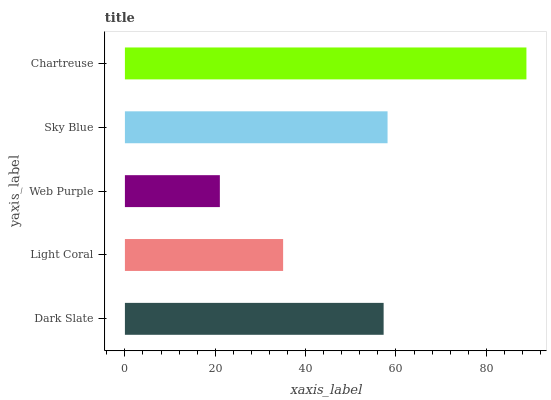Is Web Purple the minimum?
Answer yes or no. Yes. Is Chartreuse the maximum?
Answer yes or no. Yes. Is Light Coral the minimum?
Answer yes or no. No. Is Light Coral the maximum?
Answer yes or no. No. Is Dark Slate greater than Light Coral?
Answer yes or no. Yes. Is Light Coral less than Dark Slate?
Answer yes or no. Yes. Is Light Coral greater than Dark Slate?
Answer yes or no. No. Is Dark Slate less than Light Coral?
Answer yes or no. No. Is Dark Slate the high median?
Answer yes or no. Yes. Is Dark Slate the low median?
Answer yes or no. Yes. Is Chartreuse the high median?
Answer yes or no. No. Is Web Purple the low median?
Answer yes or no. No. 